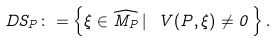<formula> <loc_0><loc_0><loc_500><loc_500>D S _ { P } \colon = \left \{ \xi \in { \widehat { M _ { P } } } \, | \ V ( P , \xi ) \neq 0 \, \right \} .</formula> 